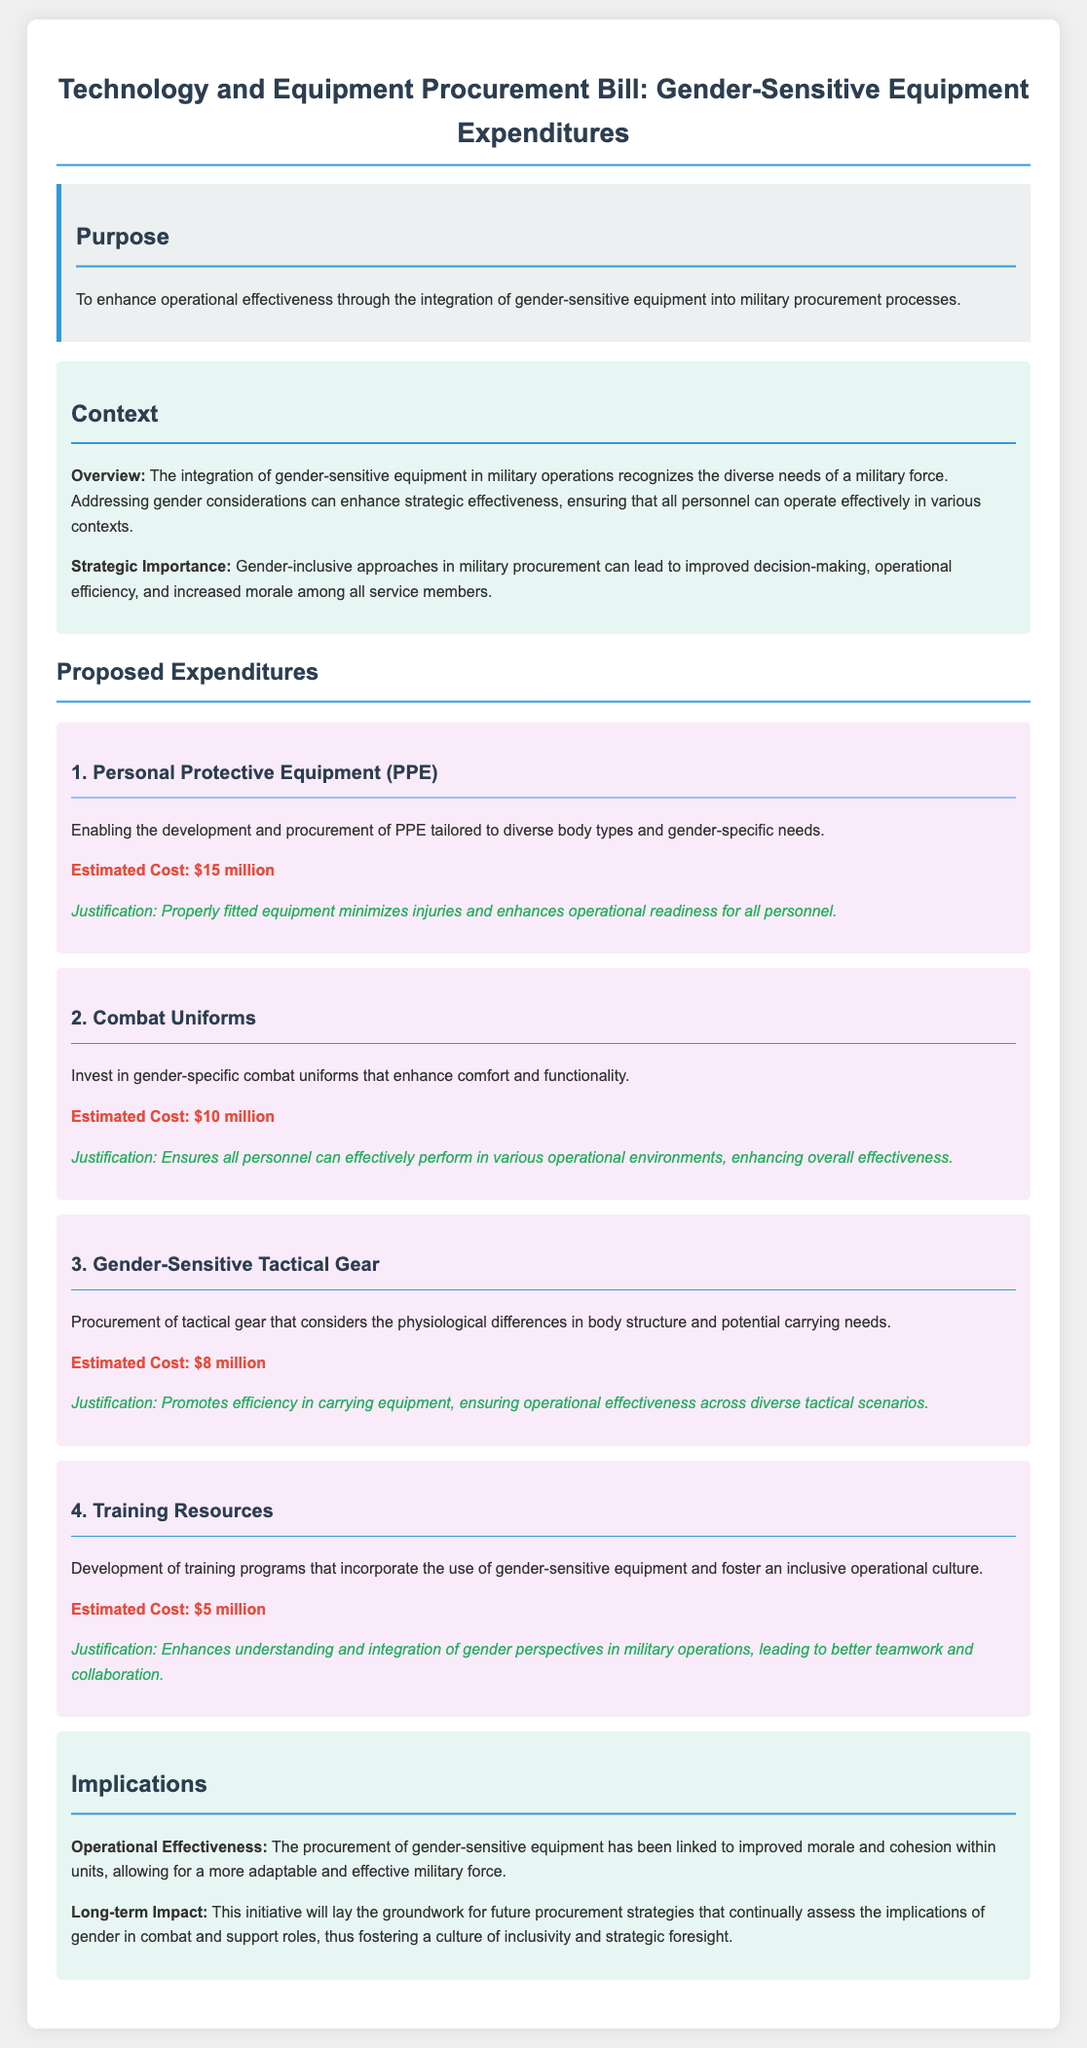What is the estimated cost for Personal Protective Equipment? The estimated cost for Personal Protective Equipment (PPE) is detailed in the expenditures section of the document.
Answer: $15 million What type of equipment is being procured for gender-specific needs? The document outlines specific types of gender-sensitive equipment being procured, including Personal Protective Equipment, Combat Uniforms, and Tactical Gear.
Answer: Personal Protective Equipment What does the bill aim to enhance? The purpose of the bill is stated at the beginning and focuses on a key goal regarding military operations.
Answer: Operational effectiveness How much is allocated for training resources? The document lists expenditure amounts for various equipment, including the development of training programs.
Answer: $5 million What is identified as a long-term impact of the initiative? The document discusses the future implications of this initiative, particularly regarding military culture.
Answer: Inclusivity What is the strategic importance of integrating gender-sensitive equipment? The context section highlights the benefits associated with recognizing gender considerations in military operations.
Answer: Improved decision-making How many expenditure areas are listed in the document? The document outlines multiple specific areas of expenditure related to gender-sensitive equipment in the military.
Answer: Four What justification is given for gender-specific combat uniforms? The expenditure section provides reasoning for why this type of equipment is essential in military contexts.
Answer: Ensures all personnel can effectively perform in various operational environments What is emphasized as a benefit of gender-sensitive tactical gear? The document explains the implications of procurement decisions on operational efficiency and military effectiveness.
Answer: Promotes efficiency in carrying equipment 